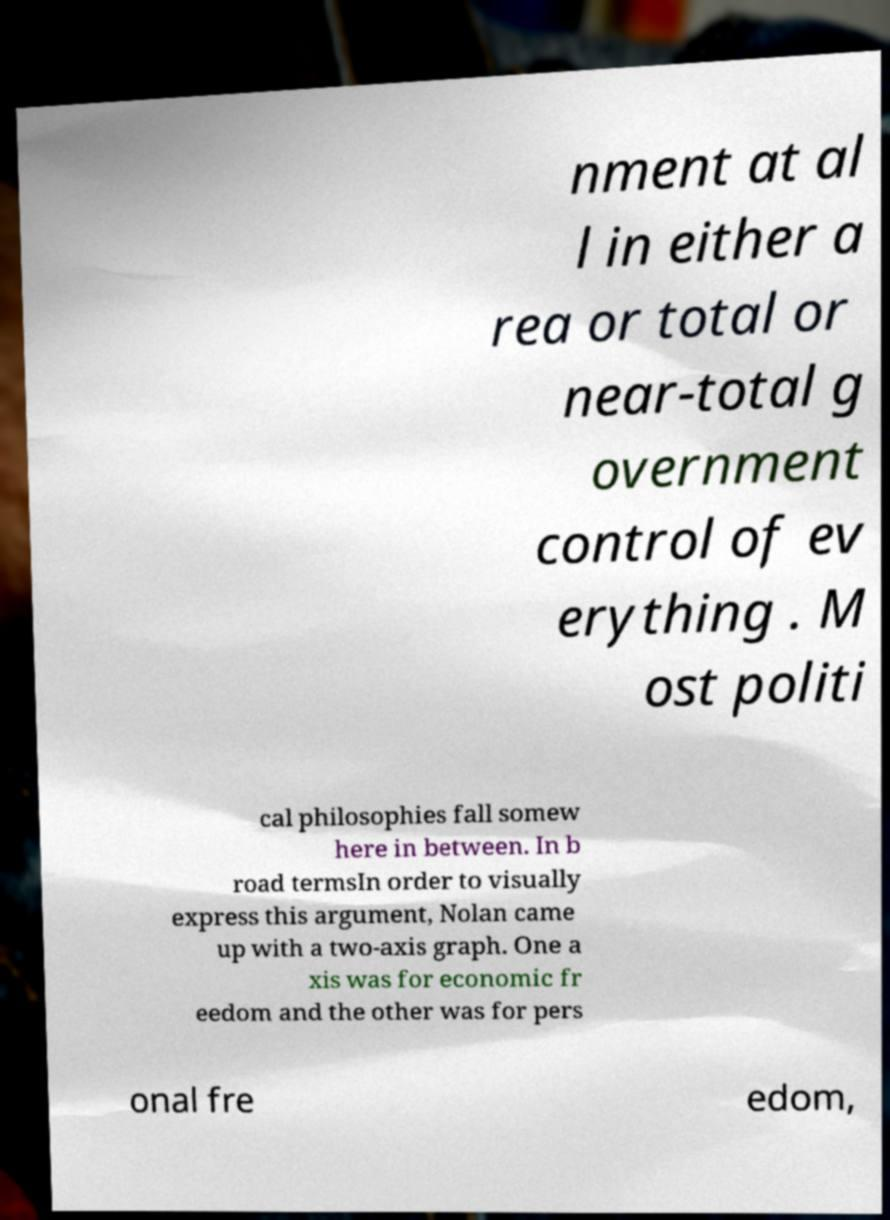Please read and relay the text visible in this image. What does it say? nment at al l in either a rea or total or near-total g overnment control of ev erything . M ost politi cal philosophies fall somew here in between. In b road termsIn order to visually express this argument, Nolan came up with a two-axis graph. One a xis was for economic fr eedom and the other was for pers onal fre edom, 